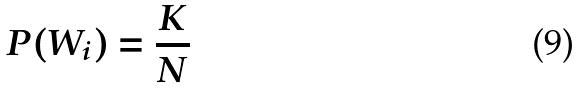Convert formula to latex. <formula><loc_0><loc_0><loc_500><loc_500>P ( W _ { i } ) = \frac { K } { N }</formula> 